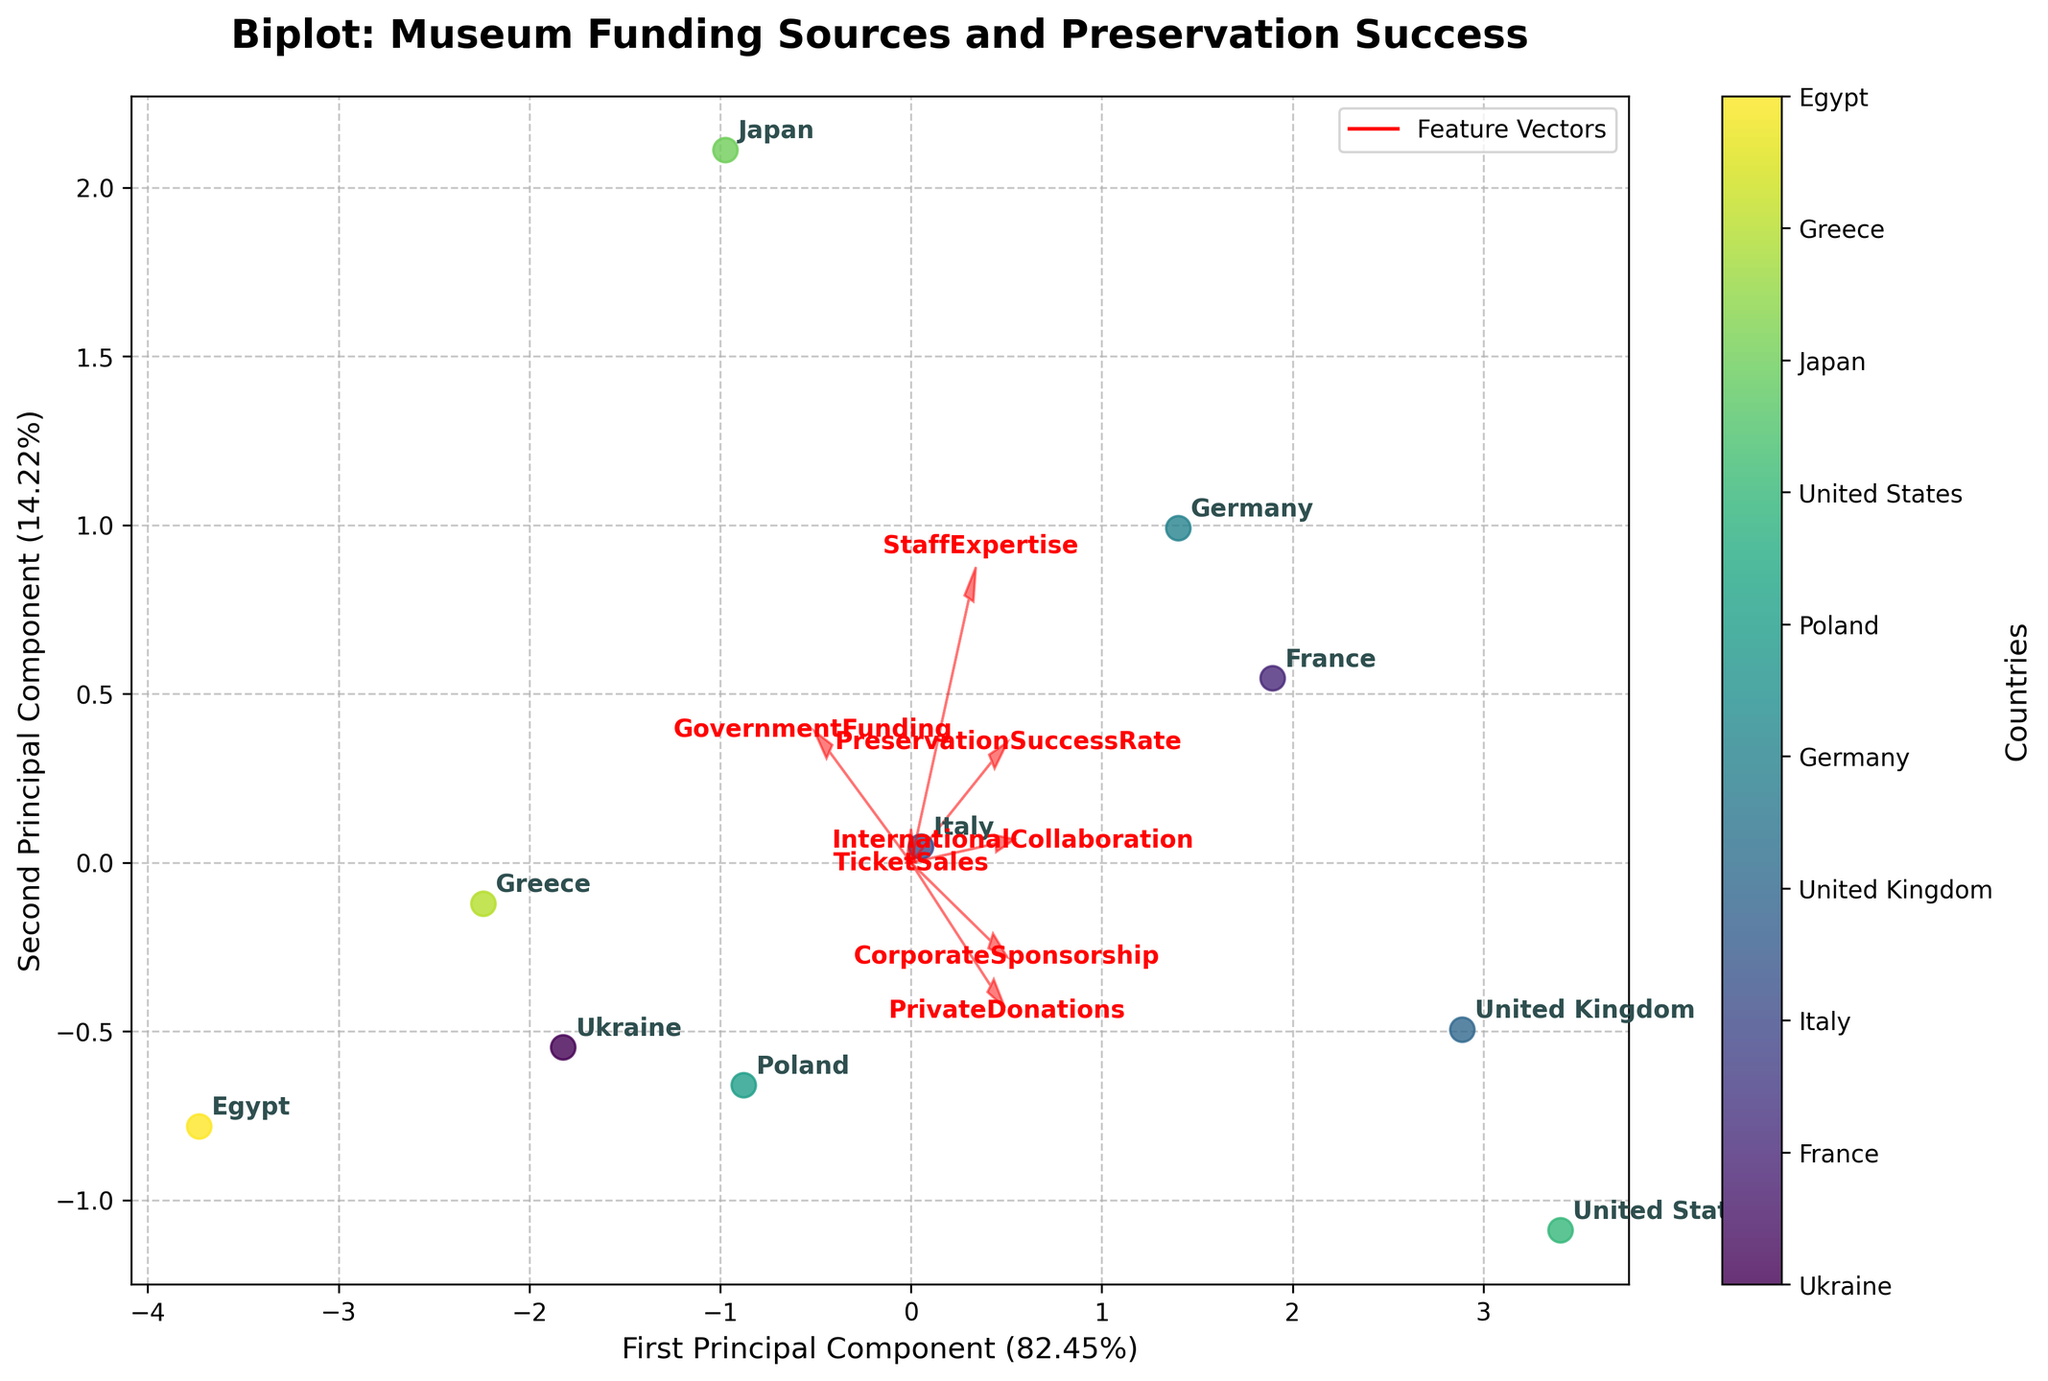What's the title of the plot? The title of the plot is displayed at the top, using a bold and larger font to make it easily noticeable. The title reads "Biplot: Museum Funding Sources and Preservation Success".
Answer: Biplot: Museum Funding Sources and Preservation Success How many countries are displayed in the plot? Each country's position is represented by a dot with a country label next to it. By counting these labels, we see there are ten countries shown.
Answer: 10 What are the axes representing in this Biplot? The X-axis represents the First Principal Component, while the Y-axis represents the Second Principal Component. This is indicated by the labels along the axes.
Answer: First and Second Principal Components Which country has the highest representation on the second principal component? By locating the country point farthest in the positive direction of the Y-axis (Second Principal Component), we see the United Kingdom is positioned there.
Answer: United Kingdom Which vector appears to contribute most to the first principal component? By examining the feature vectors originating from the origin, the 'GovernmentFunding' vector stretches the farthest in the horizontal direction, indicating its significant contribution.
Answer: GovernmentFunding How closely associated are 'PrivateDonations' and 'TicketSales' in the plot? Observing the direction and proximity of the feature vectors indicates that 'PrivateDonations' and 'TicketSales' are nearly parallel and close, implying they are strongly associated.
Answer: Strongly associated What is the relationship between 'StaffExpertise' and the preservation success rate? By examining the vectors for 'StaffExpertise' and 'PreservationSuccessRate', they seem to point in similar directions, indicating a positive correlation.
Answer: Positive correlation Which country falls closest to the origin, and what does this imply? The point representing Greece is nearest to the origin, implying that Greece's characteristics do not deviate substantially from the average values after PCA transformation.
Answer: Greece Which two countries have the most distinct separation on the plot? Observing the scatter plot, Egypt and the United Kingdom are positioned at almost opposite ends, indicating the greatest distinction between these two countries.
Answer: Egypt and the United Kingdom 